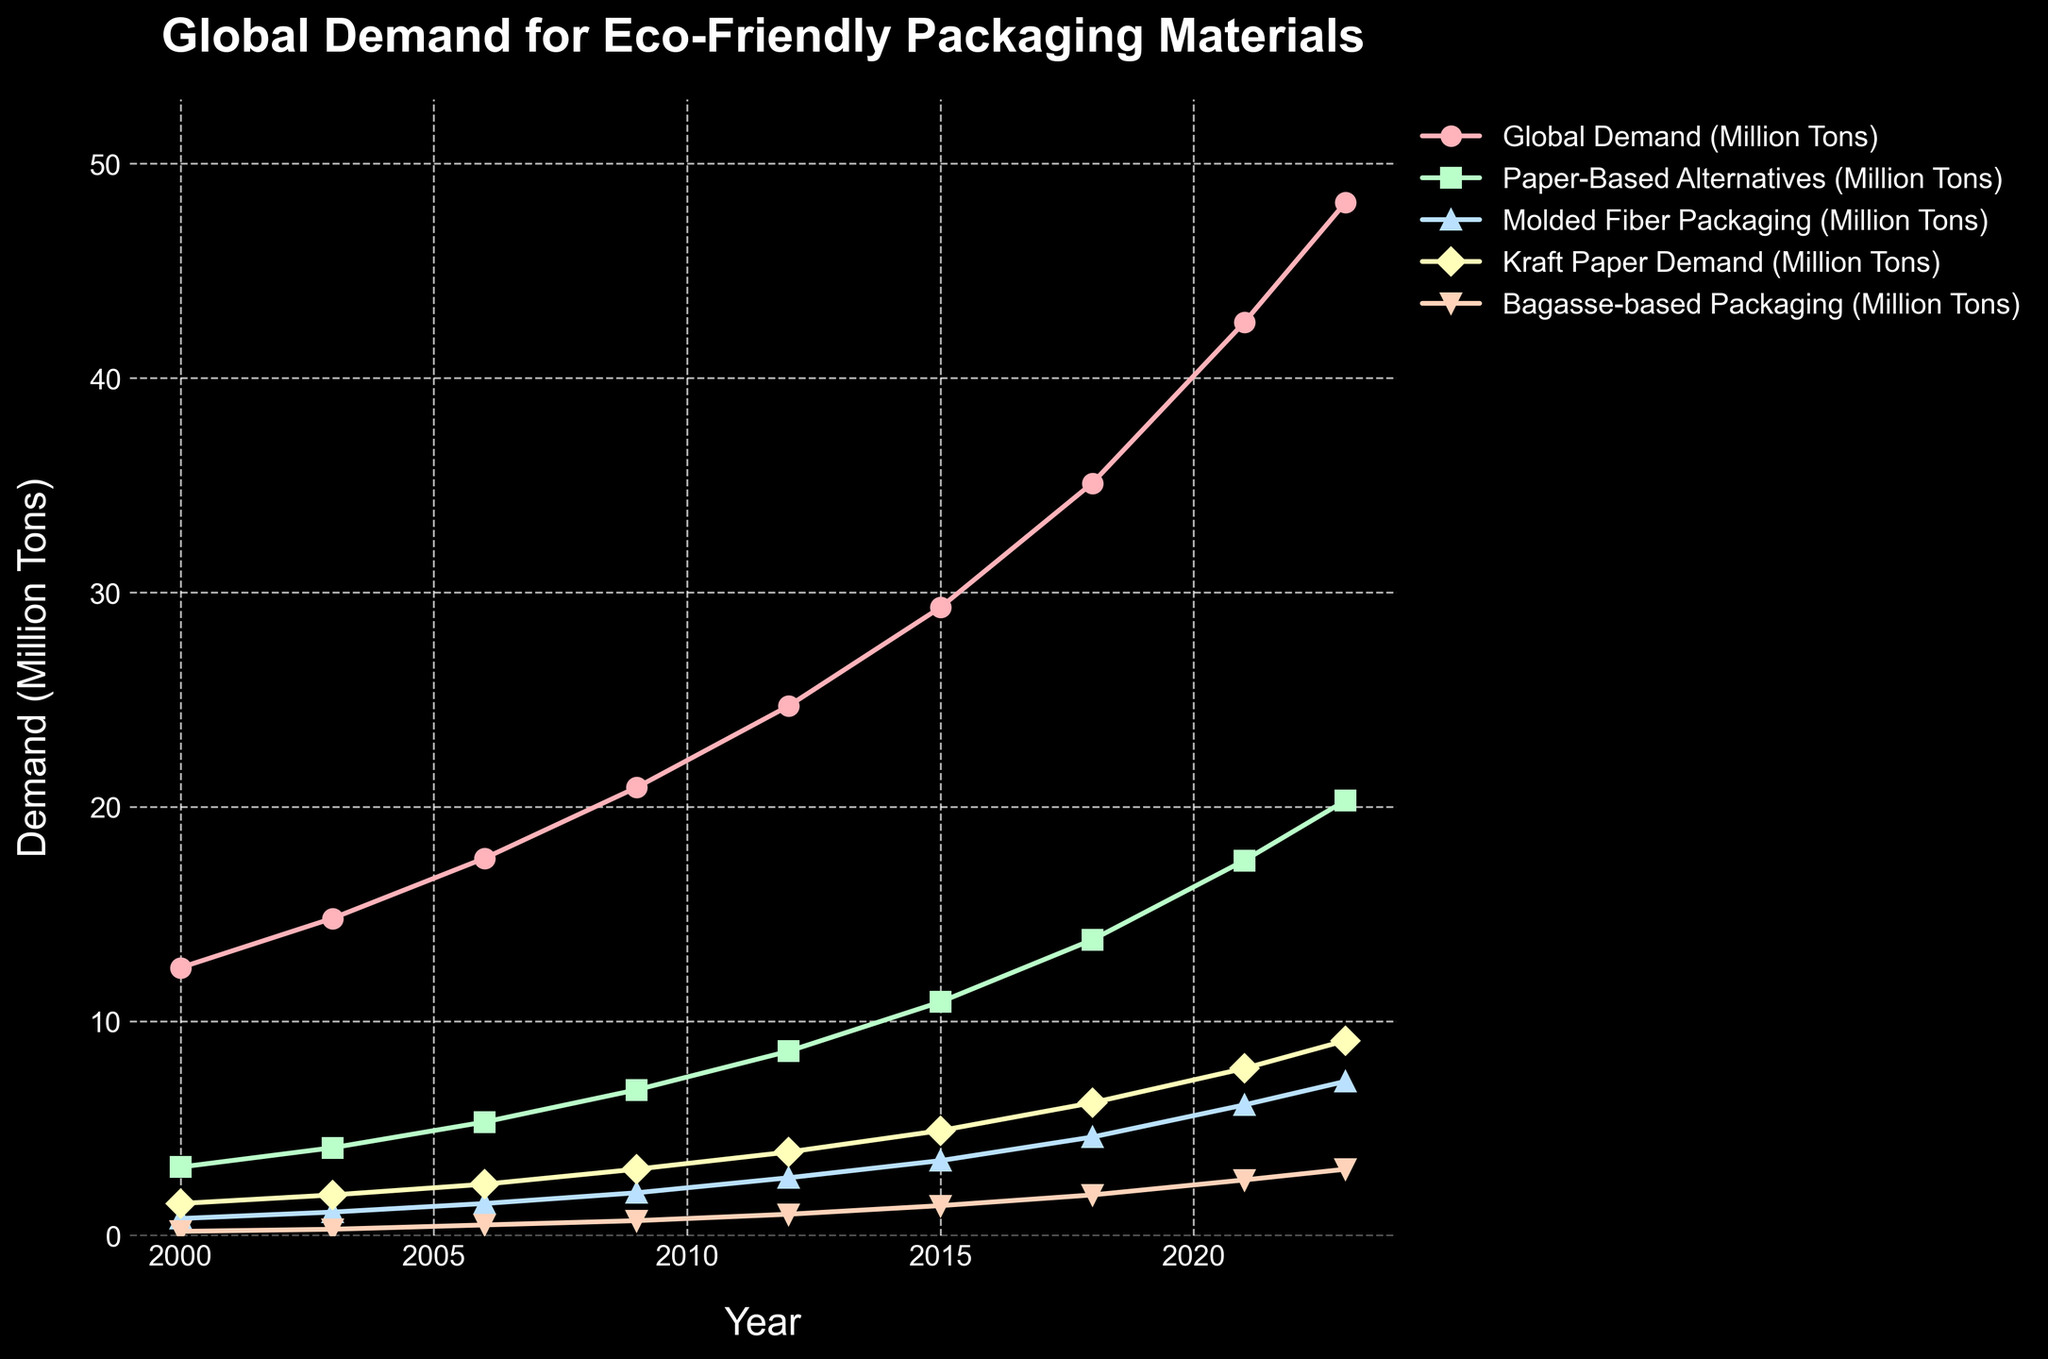What trend can be observed in the demand for paper-based alternatives from 2000 to 2023? The demand for paper-based alternatives has been steadily increasing from 3.2 million tons in 2000 to 20.3 million tons in 2023, indicating a growing preference for this type of eco-friendly packaging
Answer: Increasing How does the demand for molded fiber packaging in 2023 compare to that in 2000? The demand for molded fiber packaging was 0.8 million tons in 2000 and increased to 7.2 million tons in 2023, which is an increase of 6.4 million tons
Answer: 7.2 million tons By how much did the total global demand for eco-friendly packaging materials grow between 2000 and 2023? The global demand in 2000 was 12.5 million tons and it grew to 48.2 million tons in 2023. The increase is 48.2 - 12.5 = 35.7 million tons
Answer: 35.7 million tons Calculate the average demand for bagasse-based packaging from 2000 to 2023. Add the demand values for bagasse-based packaging from 2000 to 2023: (0.2 + 0.3 + 0.5 + 0.7 + 1.0 + 1.4 + 1.9 + 2.6 + 3.1) = 11.7. Then divide by the number of years (9): 11.7 / 9 = 1.3 million tons
Answer: 1.3 million tons Which type of eco-friendly packaging had the highest growth percentage from 2000 to 2023? Calculate the growth percentage for each category: Paper-Based Alternatives (20.3-3.2)/3.2*100 = 534.4%, Molded Fiber Packaging (7.2-0.8)/0.8*100 = 800%, Kraft Paper Demand (9.1-1.5)/1.5*100 = 506.7%, Bagasse-based Packaging (3.1-0.2)/0.2*100 = 1450%. Bagasse-based packaging had the highest growth percentage
Answer: Bagasse-based packaging Compare the demands for kraft paper and paper-based alternatives in 2018. In 2018, the demand for kraft paper was 6.2 million tons while the demand for paper-based alternatives was 13.8 million tons. Paper-based alternatives had a higher demand
Answer: Paper-based alternatives What is the total demand for all eco-friendly packaging materials in 2015? Add the demand values for each type of packaging in 2015: 10.9 (paper-based) + 3.5 (molded fiber) + 4.9 (kraft paper) + 1.4 (bagasse) = 20.7 million tons
Answer: 20.7 million tons What is the difference between the demand for paper-based alternatives and kraft paper in 2023? In 2023, the demand for paper-based alternatives was 20.3 million tons and for kraft paper it was 9.1 million tons. The difference is 20.3 - 9.1 = 11.2 million tons
Answer: 11.2 million tons How did the demand for molded fiber packaging change between 2000 and 2009? In 2000, the demand for molded fiber packaging was 0.8 million tons, and by 2009 it increased to 2.0 million tons. The change is 2.0 - 0.8 = 1.2 million tons
Answer: 1.2 million tons What is the overall trend for eco-friendly packaging materials from 2000 to 2023? The overall trend for all types of eco-friendly packaging materials, including paper-based alternatives, molded fiber packaging, kraft paper, and bagasse-based packaging, shows a continuous and significant increase in demand over the years
Answer: Increasing 